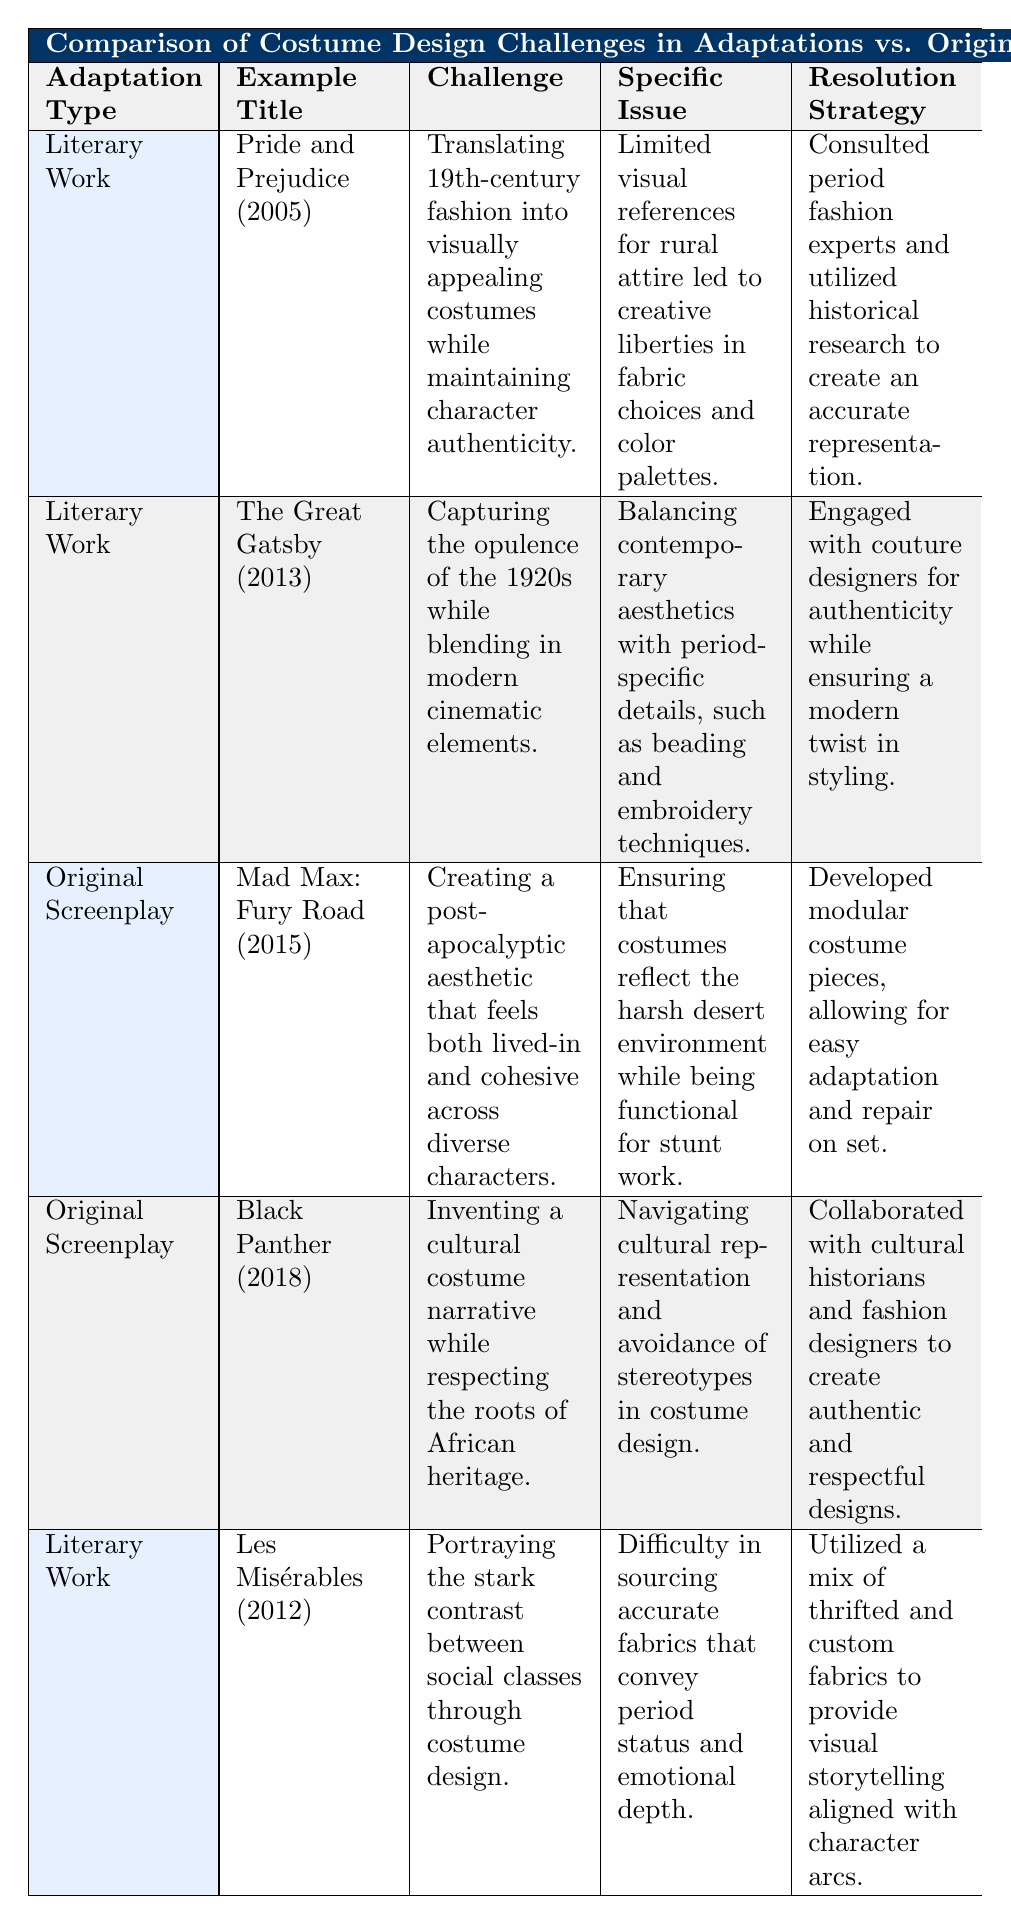What is the specific issue faced in "Pride and Prejudice (2005)"? The table directly states that the specific issue faced in "Pride and Prejudice (2005)" was the limited visual references for rural attire, which led to creative liberties in fabric choices and color palettes.
Answer: Limited visual references for rural attire Which adaptation type does "Black Panther (2018)" belong to? "Black Panther (2018)" is categorized under the adaptation type "Original Screenplay" in the table.
Answer: Original Screenplay How many costume design challenges are listed for Literary Works? By examining the table, we can list the challenges for Literary Works, which are "Translating 19th-century fashion," "Capturing the opulence of the 1920s," and "Portraying the stark contrast between social classes." That's a total of three challenges.
Answer: 3 Was cultural representation a challenge in "Black Panther (2018)"? The table specifies that one of the challenges in "Black Panther (2018)" was navigating cultural representation and avoiding stereotypes in costume design, which confirms that it was indeed a challenge.
Answer: Yes What is the resolution strategy for "Mad Max: Fury Road (2015)"? According to the table, the resolution strategy involved developing modular costume pieces that allow for easy adaptation and repair on set.
Answer: Developed modular costume pieces What was the main challenge of the costume design in "Les Misérables (2012)"? The table clearly states that the main challenge was portraying the stark contrast between social classes through costume design.
Answer: Portraying the stark contrast between social classes Which adaptation had more specific issues in costume design, Literary Works or Original Screenplays? The table features three instances categorized under Literary Works with specific issues and two instances under Original Screenplays that also list specific issues. To compare, we have a total of five instances and both categories have specific issues identified, therefore we can conclude that they are roughly equal in that aspect.
Answer: Neither, they are roughly equal 